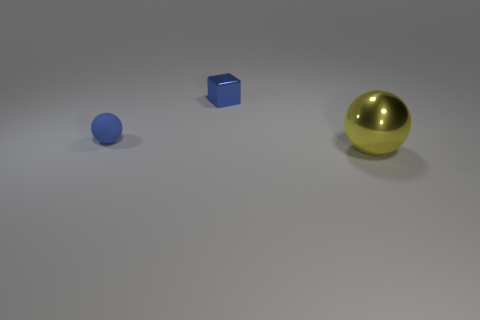Subtract all red cubes. Subtract all cyan balls. How many cubes are left? 1 Add 3 tiny green shiny balls. How many objects exist? 6 Subtract all blocks. How many objects are left? 2 Add 3 blue rubber cylinders. How many blue rubber cylinders exist? 3 Subtract 0 blue cylinders. How many objects are left? 3 Subtract all tiny blue metallic things. Subtract all large metal objects. How many objects are left? 1 Add 1 large yellow shiny spheres. How many large yellow shiny spheres are left? 2 